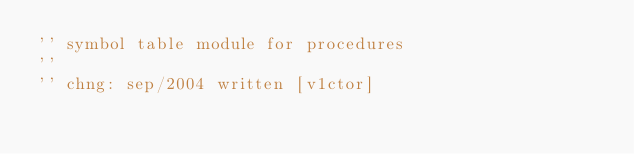Convert code to text. <code><loc_0><loc_0><loc_500><loc_500><_VisualBasic_>'' symbol table module for procedures
''
'' chng: sep/2004 written [v1ctor]</code> 